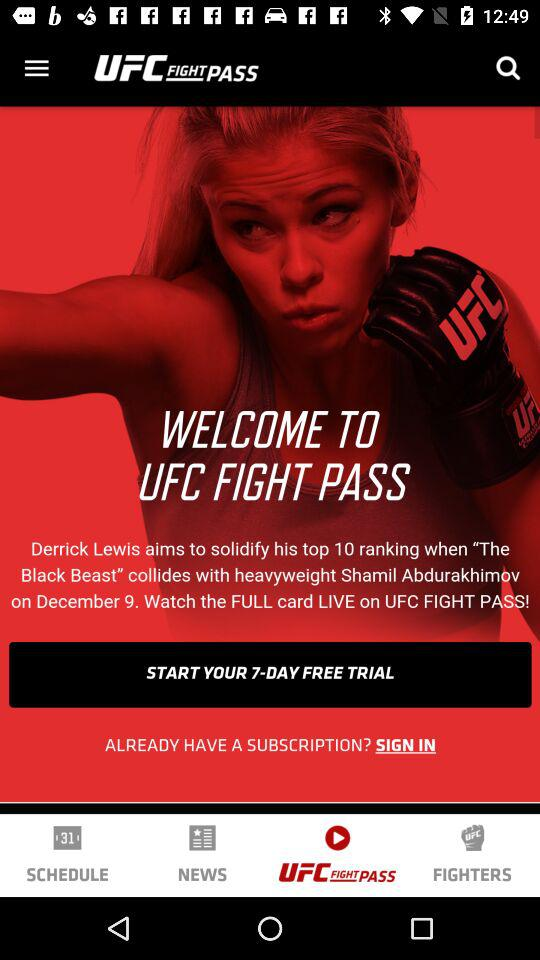On what date will the match be played? The match will be played on December 9. 